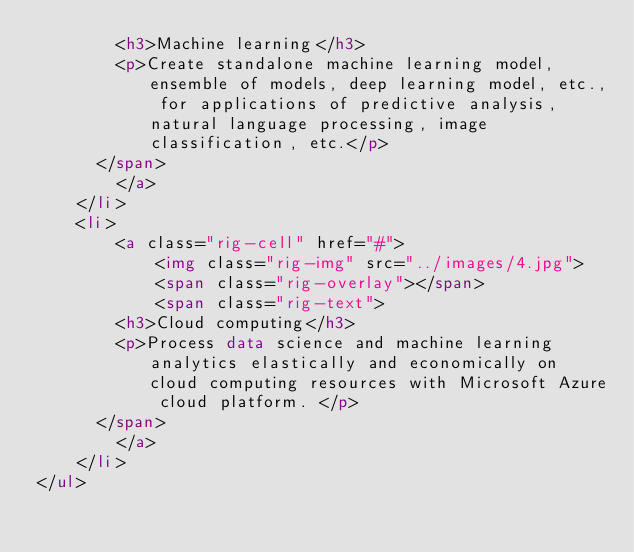<code> <loc_0><loc_0><loc_500><loc_500><_HTML_>		    <h3>Machine learning</h3>
		    <p>Create standalone machine learning model, ensemble of models, deep learning model, etc., for applications of predictive analysis, natural language processing, image classification, etc.</p> 
	    </span>
        </a>
    </li>
    <li>
        <a class="rig-cell" href="#">
            <img class="rig-img" src="../images/4.jpg">
            <span class="rig-overlay"></span>
            <span class="rig-text">
		    <h3>Cloud computing</h3> 
		    <p>Process data science and machine learning analytics elastically and economically on cloud computing resources with Microsoft Azure cloud platform. </p>
	    </span>
        </a>
    </li>
</ul>

</code> 